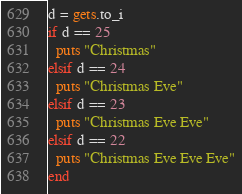Convert code to text. <code><loc_0><loc_0><loc_500><loc_500><_Ruby_>d = gets.to_i
if d == 25
  puts "Christmas"
elsif d == 24
  puts "Christmas Eve"
elsif d == 23
  puts "Christmas Eve Eve"
elsif d == 22
  puts "Christmas Eve Eve Eve"
end
</code> 